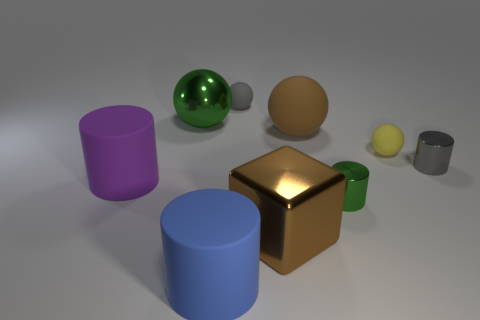Add 1 brown metallic blocks. How many objects exist? 10 Subtract all spheres. How many objects are left? 5 Add 8 large purple cylinders. How many large purple cylinders exist? 9 Subtract 1 yellow spheres. How many objects are left? 8 Subtract all large gray rubber cubes. Subtract all metallic things. How many objects are left? 5 Add 6 big purple matte cylinders. How many big purple matte cylinders are left? 7 